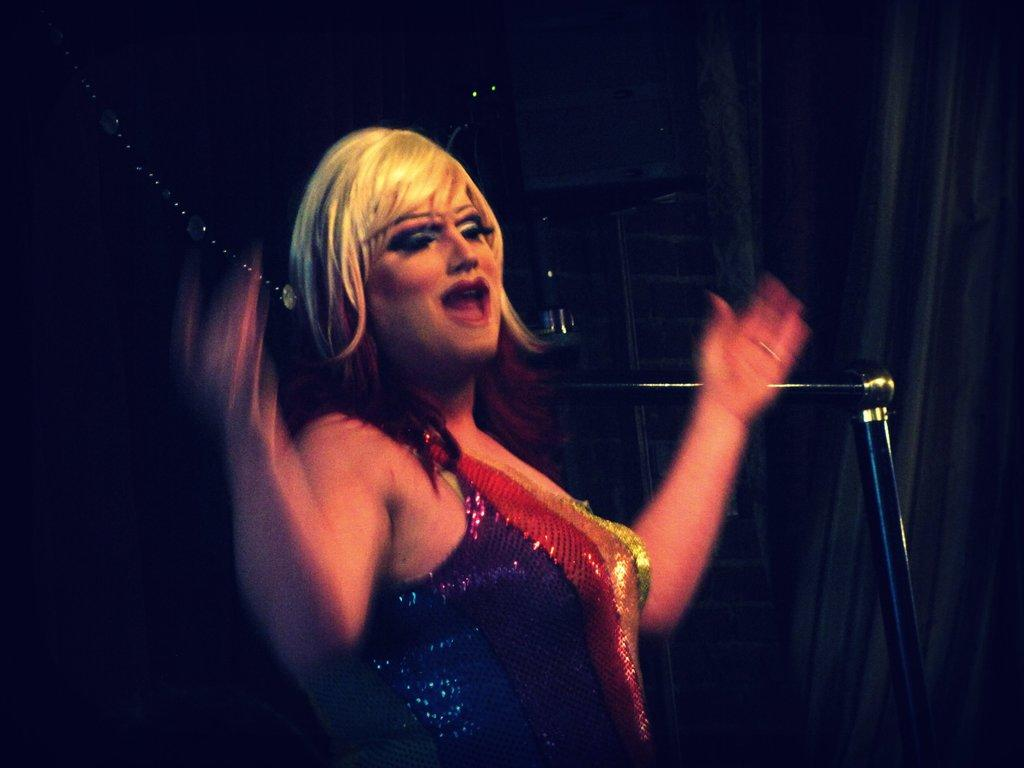Who is present in the image? There is a woman in the image. What else can be seen in the image besides the woman? There are objects in the image. What is the color of the background in the image? The background of the image is dark. Can you describe the goose's experience in the image? There is no goose present in the image, so it is not possible to describe its experience. 